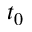Convert formula to latex. <formula><loc_0><loc_0><loc_500><loc_500>t _ { 0 }</formula> 